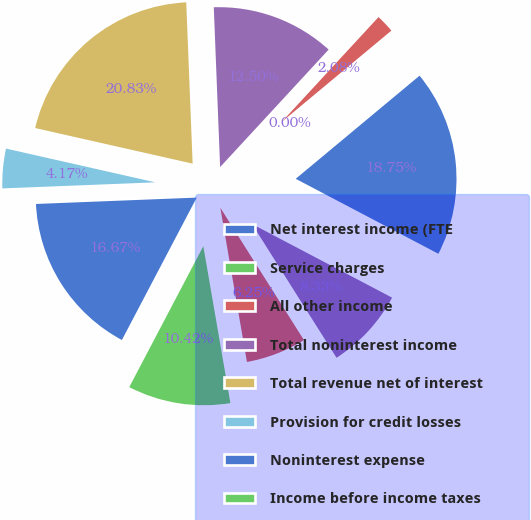Convert chart. <chart><loc_0><loc_0><loc_500><loc_500><pie_chart><fcel>Net interest income (FTE<fcel>Service charges<fcel>All other income<fcel>Total noninterest income<fcel>Total revenue net of interest<fcel>Provision for credit losses<fcel>Noninterest expense<fcel>Income before income taxes<fcel>Income tax expense (FTE basis)<fcel>Net income<nl><fcel>18.75%<fcel>0.0%<fcel>2.08%<fcel>12.5%<fcel>20.83%<fcel>4.17%<fcel>16.67%<fcel>10.42%<fcel>6.25%<fcel>8.33%<nl></chart> 